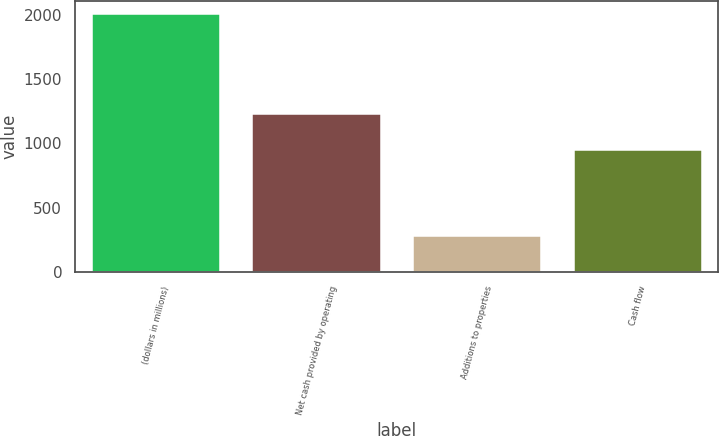Convert chart to OTSL. <chart><loc_0><loc_0><loc_500><loc_500><bar_chart><fcel>(dollars in millions)<fcel>Net cash provided by operating<fcel>Additions to properties<fcel>Cash flow<nl><fcel>2004<fcel>1229<fcel>278.6<fcel>950.4<nl></chart> 